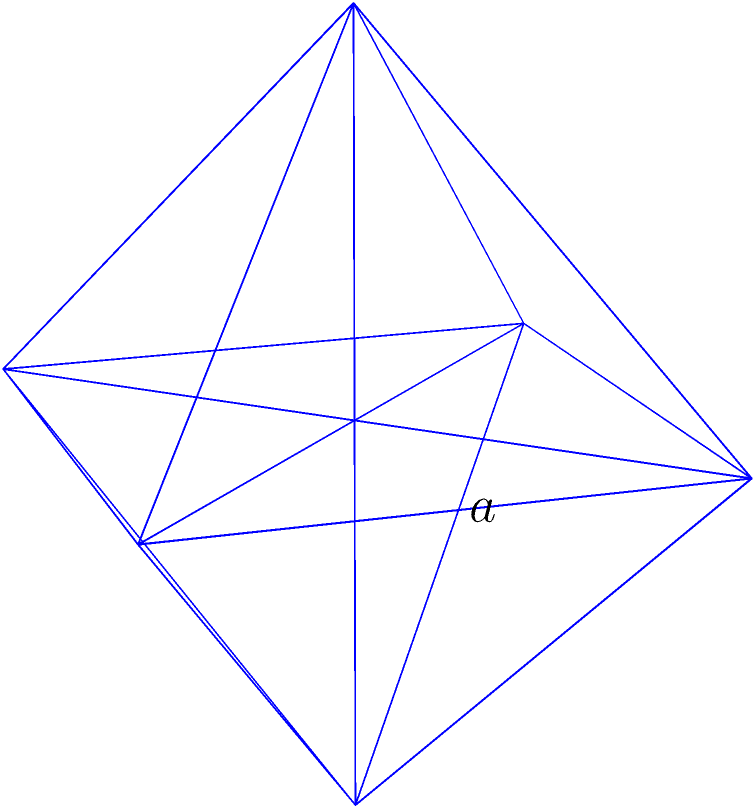As a software engineer developing applications to increase public access to legal resources, you're working on a 3D visualization of courtroom layouts. You need to calculate the surface area of an octahedral object in the courtroom. Given that the edge length of this regular octahedron is $a$ units, determine its total surface area. To find the surface area of a regular octahedron, we can follow these steps:

1) A regular octahedron consists of 8 equilateral triangular faces.

2) The area of one equilateral triangle with side length $a$ is:

   $$A_{triangle} = \frac{\sqrt{3}}{4}a^2$$

3) To get the total surface area, we multiply this by 8:

   $$SA_{octahedron} = 8 \times \frac{\sqrt{3}}{4}a^2$$

4) Simplifying:

   $$SA_{octahedron} = 2\sqrt{3}a^2$$

Therefore, the surface area of a regular octahedron with edge length $a$ is $2\sqrt{3}a^2$ square units.
Answer: $2\sqrt{3}a^2$ 